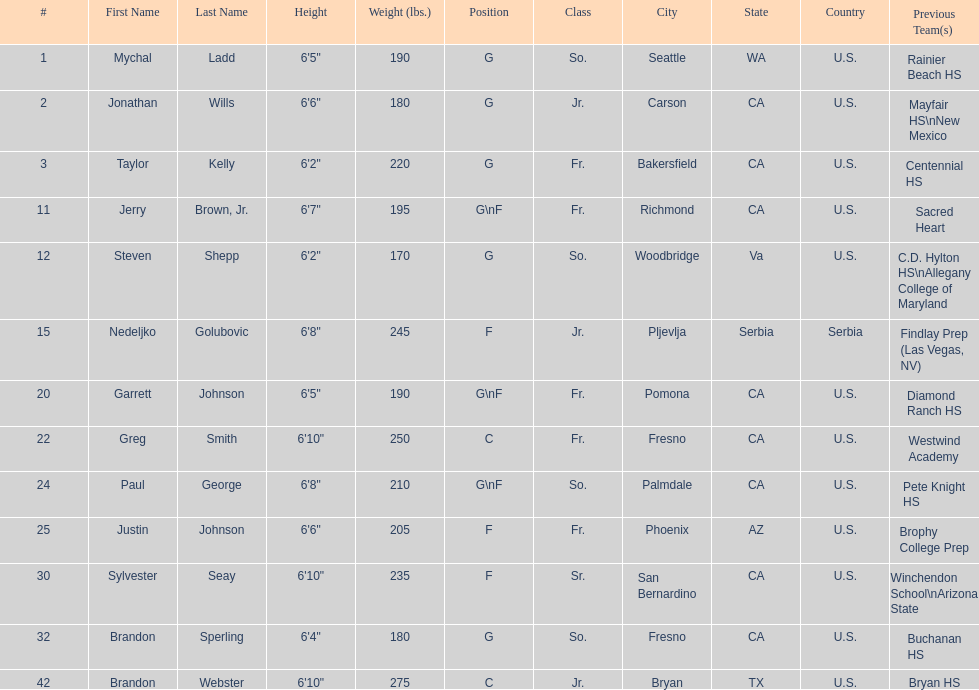Which players are forwards? Nedeljko Golubovic, Paul George, Justin Johnson, Sylvester Seay. What are the heights of these players? Nedeljko Golubovic, 6'8", Paul George, 6'8", Justin Johnson, 6'6", Sylvester Seay, 6'10". Of these players, who is the shortest? Justin Johnson. 